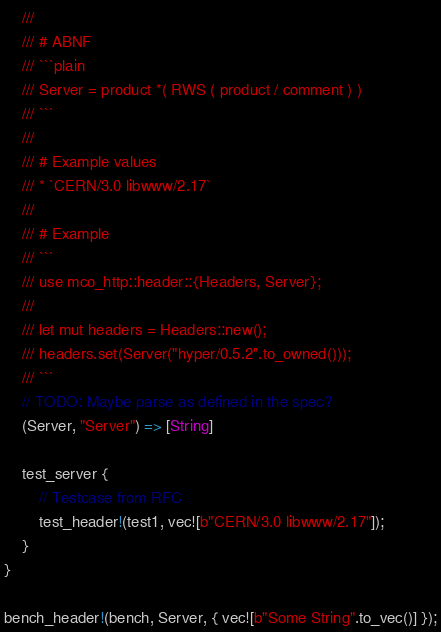Convert code to text. <code><loc_0><loc_0><loc_500><loc_500><_Rust_>    ///
    /// # ABNF
    /// ```plain
    /// Server = product *( RWS ( product / comment ) )
    /// ```
    ///
    /// # Example values
    /// * `CERN/3.0 libwww/2.17`
    ///
    /// # Example
    /// ```
    /// use mco_http::header::{Headers, Server};
    ///
    /// let mut headers = Headers::new();
    /// headers.set(Server("hyper/0.5.2".to_owned()));
    /// ```
    // TODO: Maybe parse as defined in the spec?
    (Server, "Server") => [String]

    test_server {
        // Testcase from RFC
        test_header!(test1, vec![b"CERN/3.0 libwww/2.17"]);
    }
}

bench_header!(bench, Server, { vec![b"Some String".to_vec()] });
</code> 